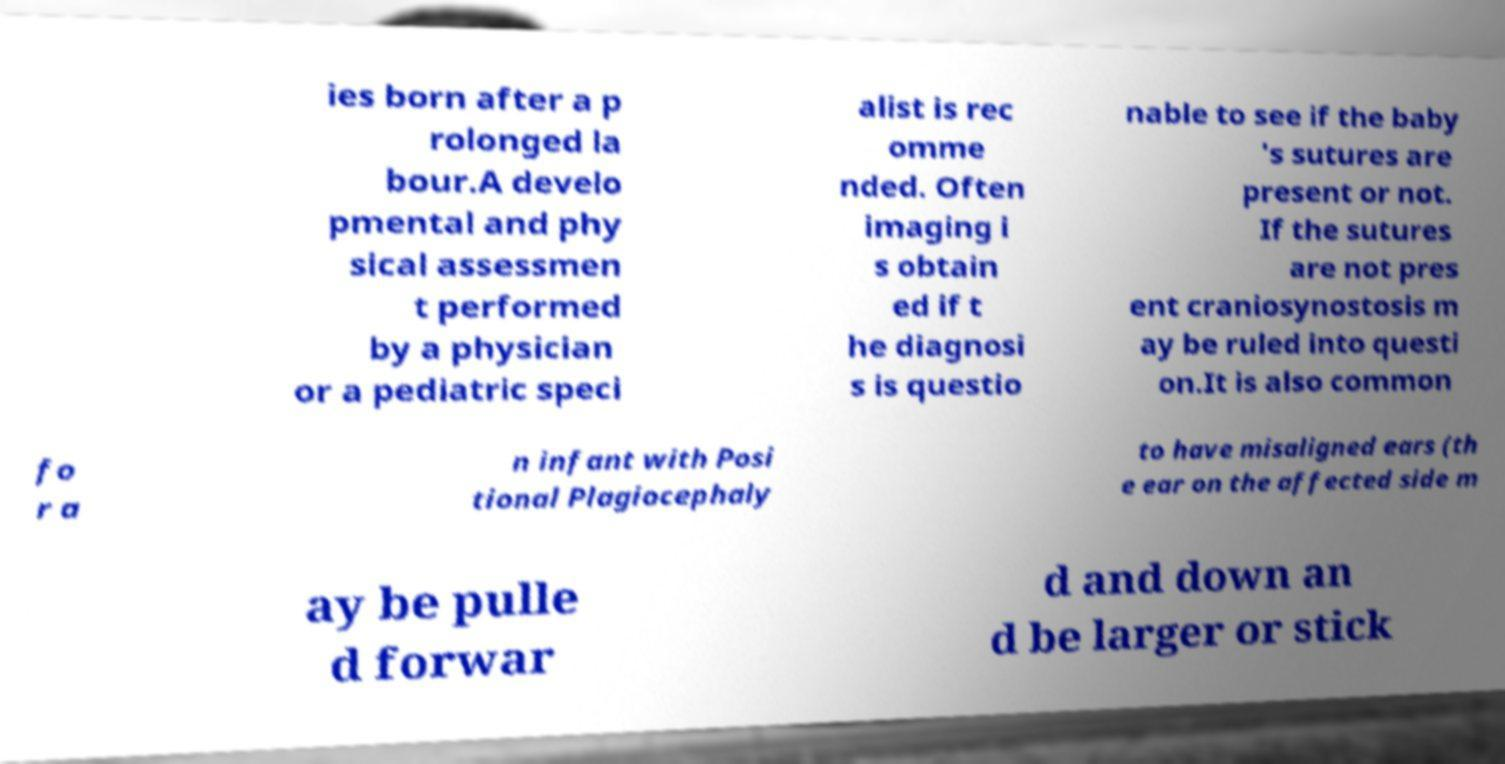Could you extract and type out the text from this image? ies born after a p rolonged la bour.A develo pmental and phy sical assessmen t performed by a physician or a pediatric speci alist is rec omme nded. Often imaging i s obtain ed if t he diagnosi s is questio nable to see if the baby 's sutures are present or not. If the sutures are not pres ent craniosynostosis m ay be ruled into questi on.It is also common fo r a n infant with Posi tional Plagiocephaly to have misaligned ears (th e ear on the affected side m ay be pulle d forwar d and down an d be larger or stick 